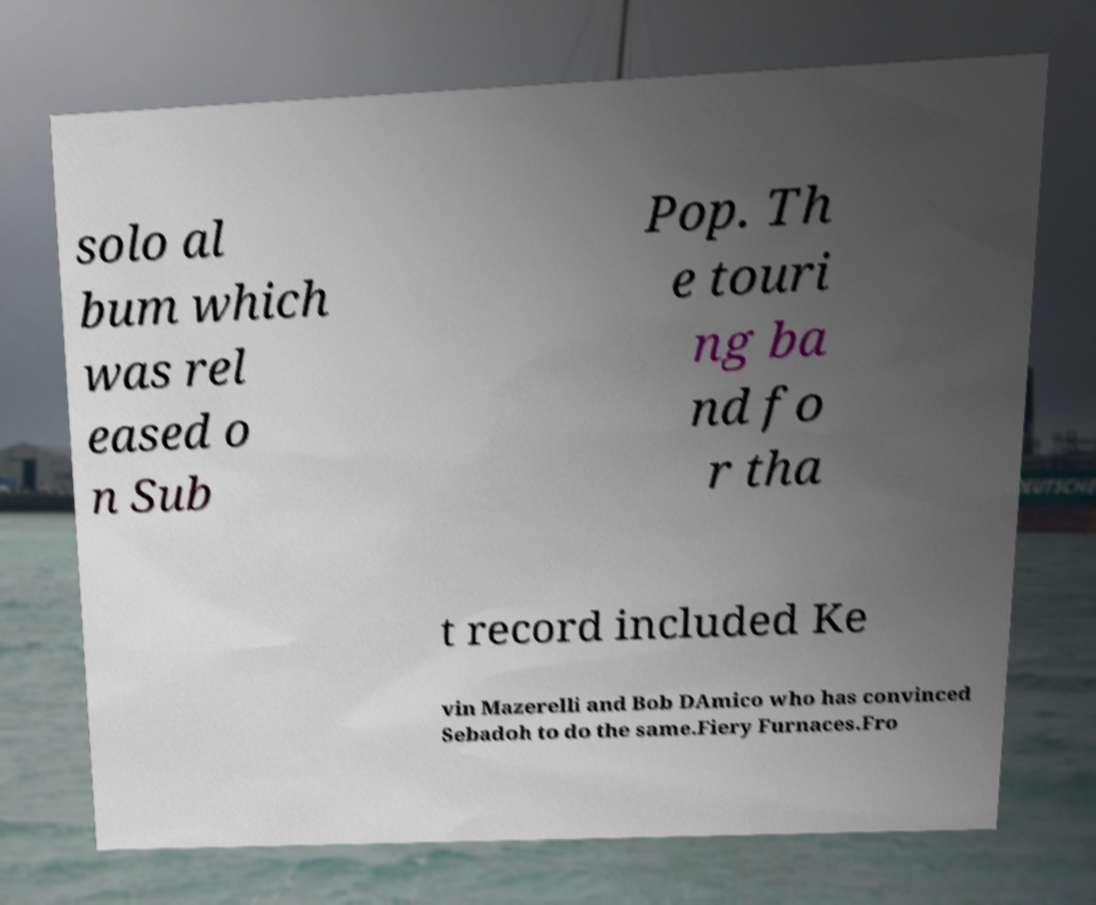There's text embedded in this image that I need extracted. Can you transcribe it verbatim? solo al bum which was rel eased o n Sub Pop. Th e touri ng ba nd fo r tha t record included Ke vin Mazerelli and Bob DAmico who has convinced Sebadoh to do the same.Fiery Furnaces.Fro 